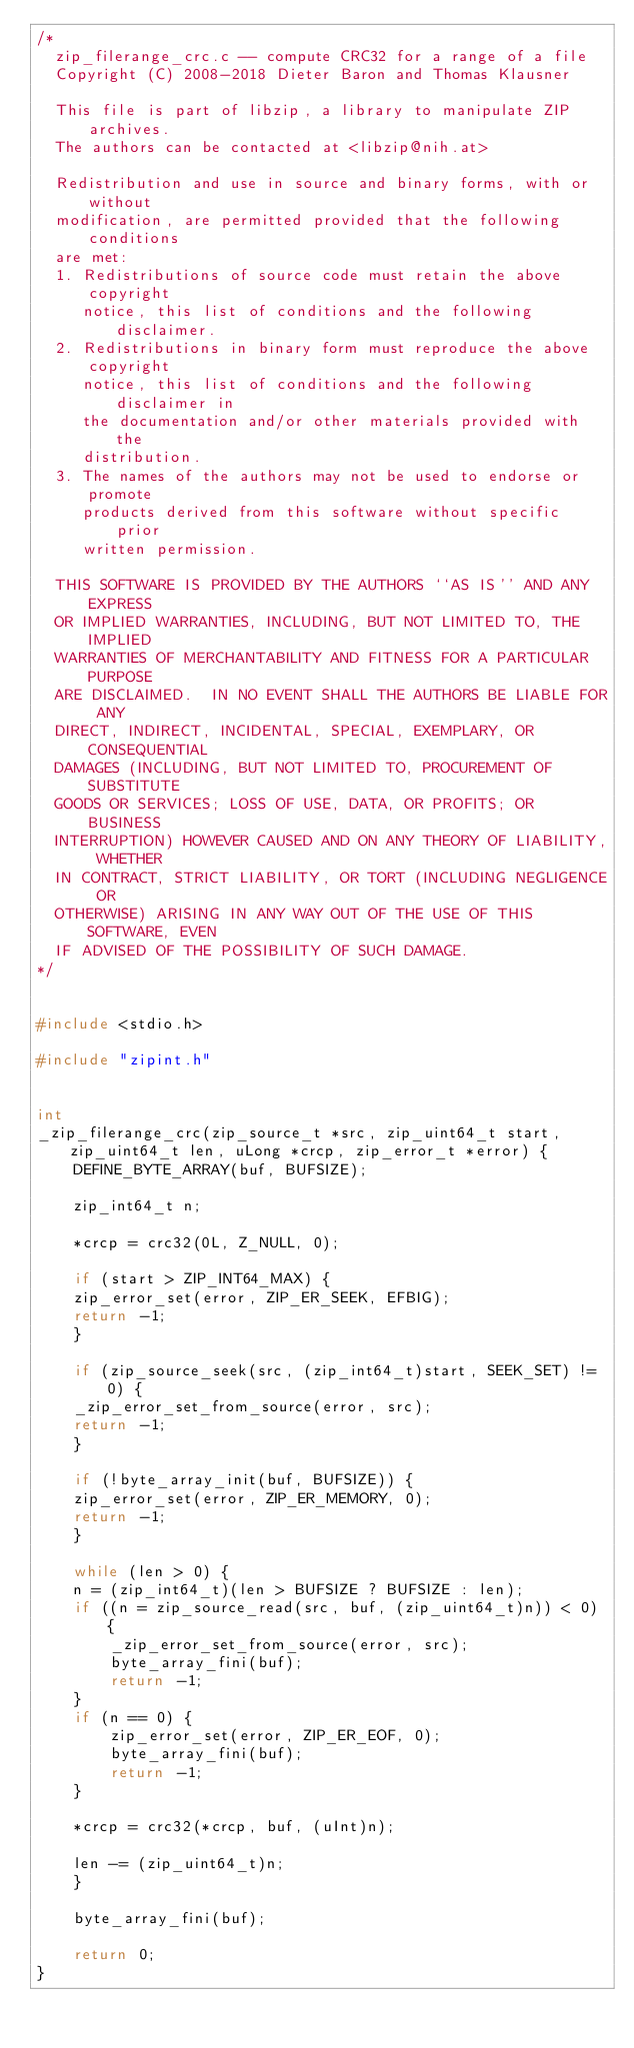<code> <loc_0><loc_0><loc_500><loc_500><_C_>/*
  zip_filerange_crc.c -- compute CRC32 for a range of a file
  Copyright (C) 2008-2018 Dieter Baron and Thomas Klausner

  This file is part of libzip, a library to manipulate ZIP archives.
  The authors can be contacted at <libzip@nih.at>

  Redistribution and use in source and binary forms, with or without
  modification, are permitted provided that the following conditions
  are met:
  1. Redistributions of source code must retain the above copyright
     notice, this list of conditions and the following disclaimer.
  2. Redistributions in binary form must reproduce the above copyright
     notice, this list of conditions and the following disclaimer in
     the documentation and/or other materials provided with the
     distribution.
  3. The names of the authors may not be used to endorse or promote
     products derived from this software without specific prior
     written permission.

  THIS SOFTWARE IS PROVIDED BY THE AUTHORS ``AS IS'' AND ANY EXPRESS
  OR IMPLIED WARRANTIES, INCLUDING, BUT NOT LIMITED TO, THE IMPLIED
  WARRANTIES OF MERCHANTABILITY AND FITNESS FOR A PARTICULAR PURPOSE
  ARE DISCLAIMED.  IN NO EVENT SHALL THE AUTHORS BE LIABLE FOR ANY
  DIRECT, INDIRECT, INCIDENTAL, SPECIAL, EXEMPLARY, OR CONSEQUENTIAL
  DAMAGES (INCLUDING, BUT NOT LIMITED TO, PROCUREMENT OF SUBSTITUTE
  GOODS OR SERVICES; LOSS OF USE, DATA, OR PROFITS; OR BUSINESS
  INTERRUPTION) HOWEVER CAUSED AND ON ANY THEORY OF LIABILITY, WHETHER
  IN CONTRACT, STRICT LIABILITY, OR TORT (INCLUDING NEGLIGENCE OR
  OTHERWISE) ARISING IN ANY WAY OUT OF THE USE OF THIS SOFTWARE, EVEN
  IF ADVISED OF THE POSSIBILITY OF SUCH DAMAGE.
*/


#include <stdio.h>

#include "zipint.h"


int
_zip_filerange_crc(zip_source_t *src, zip_uint64_t start, zip_uint64_t len, uLong *crcp, zip_error_t *error) {
    DEFINE_BYTE_ARRAY(buf, BUFSIZE);

    zip_int64_t n;

    *crcp = crc32(0L, Z_NULL, 0);

    if (start > ZIP_INT64_MAX) {
	zip_error_set(error, ZIP_ER_SEEK, EFBIG);
	return -1;
    }

    if (zip_source_seek(src, (zip_int64_t)start, SEEK_SET) != 0) {
	_zip_error_set_from_source(error, src);
	return -1;
    }

    if (!byte_array_init(buf, BUFSIZE)) {
	zip_error_set(error, ZIP_ER_MEMORY, 0);
	return -1;
    }

    while (len > 0) {
	n = (zip_int64_t)(len > BUFSIZE ? BUFSIZE : len);
	if ((n = zip_source_read(src, buf, (zip_uint64_t)n)) < 0) {
	    _zip_error_set_from_source(error, src);
	    byte_array_fini(buf);
	    return -1;
	}
	if (n == 0) {
	    zip_error_set(error, ZIP_ER_EOF, 0);
	    byte_array_fini(buf);
	    return -1;
	}

	*crcp = crc32(*crcp, buf, (uInt)n);

	len -= (zip_uint64_t)n;
    }

    byte_array_fini(buf);

    return 0;
}
</code> 